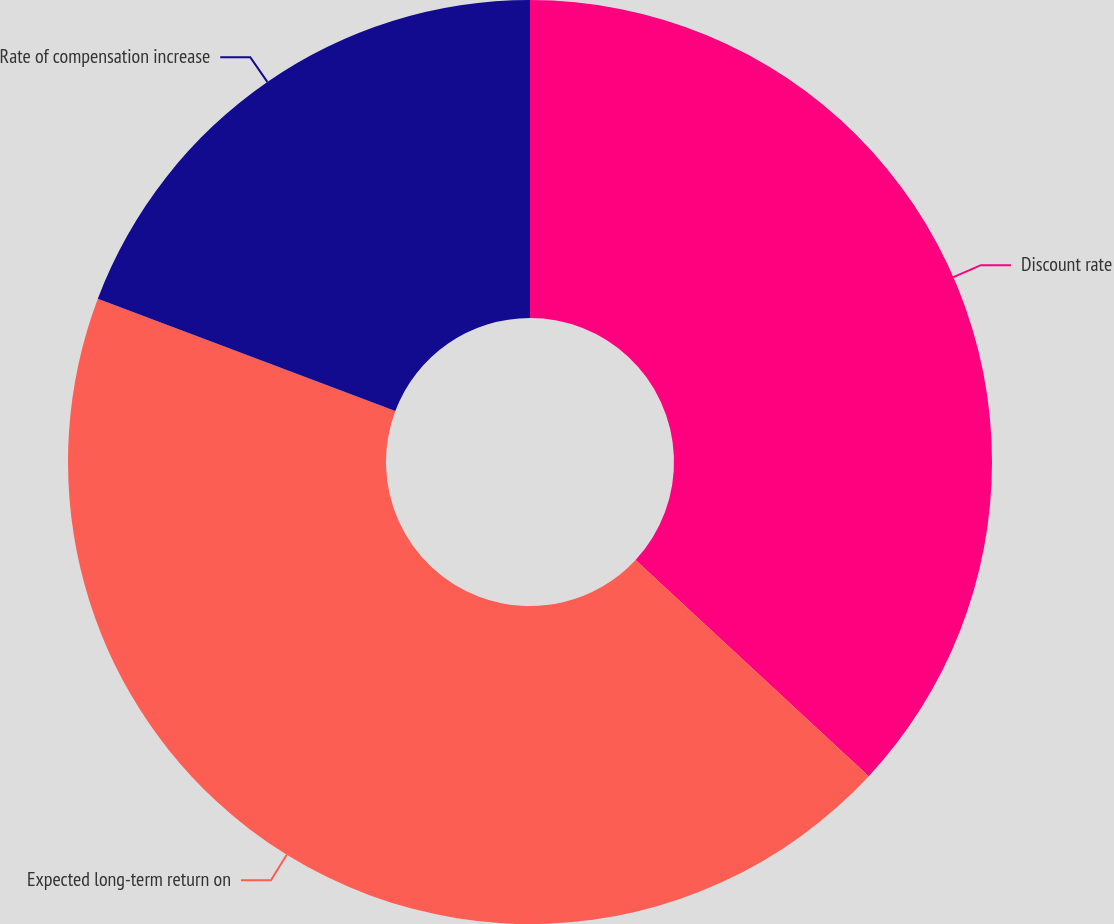Convert chart to OTSL. <chart><loc_0><loc_0><loc_500><loc_500><pie_chart><fcel>Discount rate<fcel>Expected long-term return on<fcel>Rate of compensation increase<nl><fcel>36.9%<fcel>43.85%<fcel>19.25%<nl></chart> 